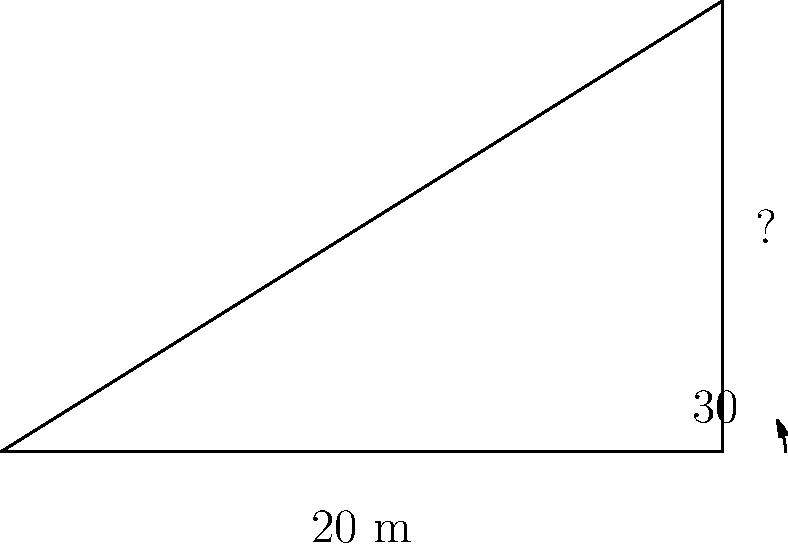During a political rally at the Champ de Mars in Port Louis, you notice a tall flag pole. Standing 20 meters away from its base, you measure the angle of elevation to the top of the pole to be 30°. Calculate the height of the flag pole to the nearest meter. Let's approach this step-by-step:

1) We can use the tangent function to solve this problem. The tangent of an angle in a right triangle is the ratio of the opposite side to the adjacent side.

2) In this case:
   - The angle of elevation is 30°
   - The adjacent side (distance from the observer to the base of the pole) is 20 meters
   - The opposite side (height of the pole) is what we're trying to find

3) Let's call the height of the pole $h$. We can write the equation:

   $$\tan(30°) = \frac{h}{20}$$

4) We know that $\tan(30°) = \frac{1}{\sqrt{3}} \approx 0.577$

5) Substituting this value:

   $$0.577 = \frac{h}{20}$$

6) To solve for $h$, multiply both sides by 20:

   $$h = 20 \times 0.577 = 11.54$$

7) Rounding to the nearest meter:

   $$h \approx 12\text{ meters}$$
Answer: 12 meters 